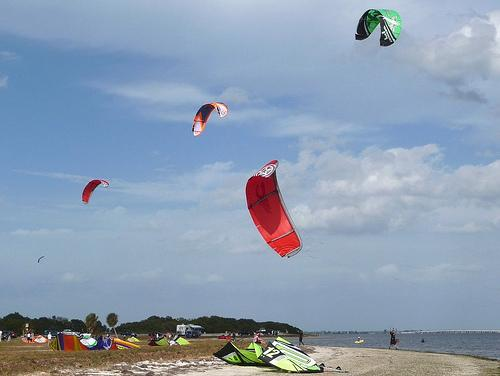The inflatable wing used to fly in which game?

Choices:
A) skating
B) paragliding
C) kiting
D) parachuting paragliding 